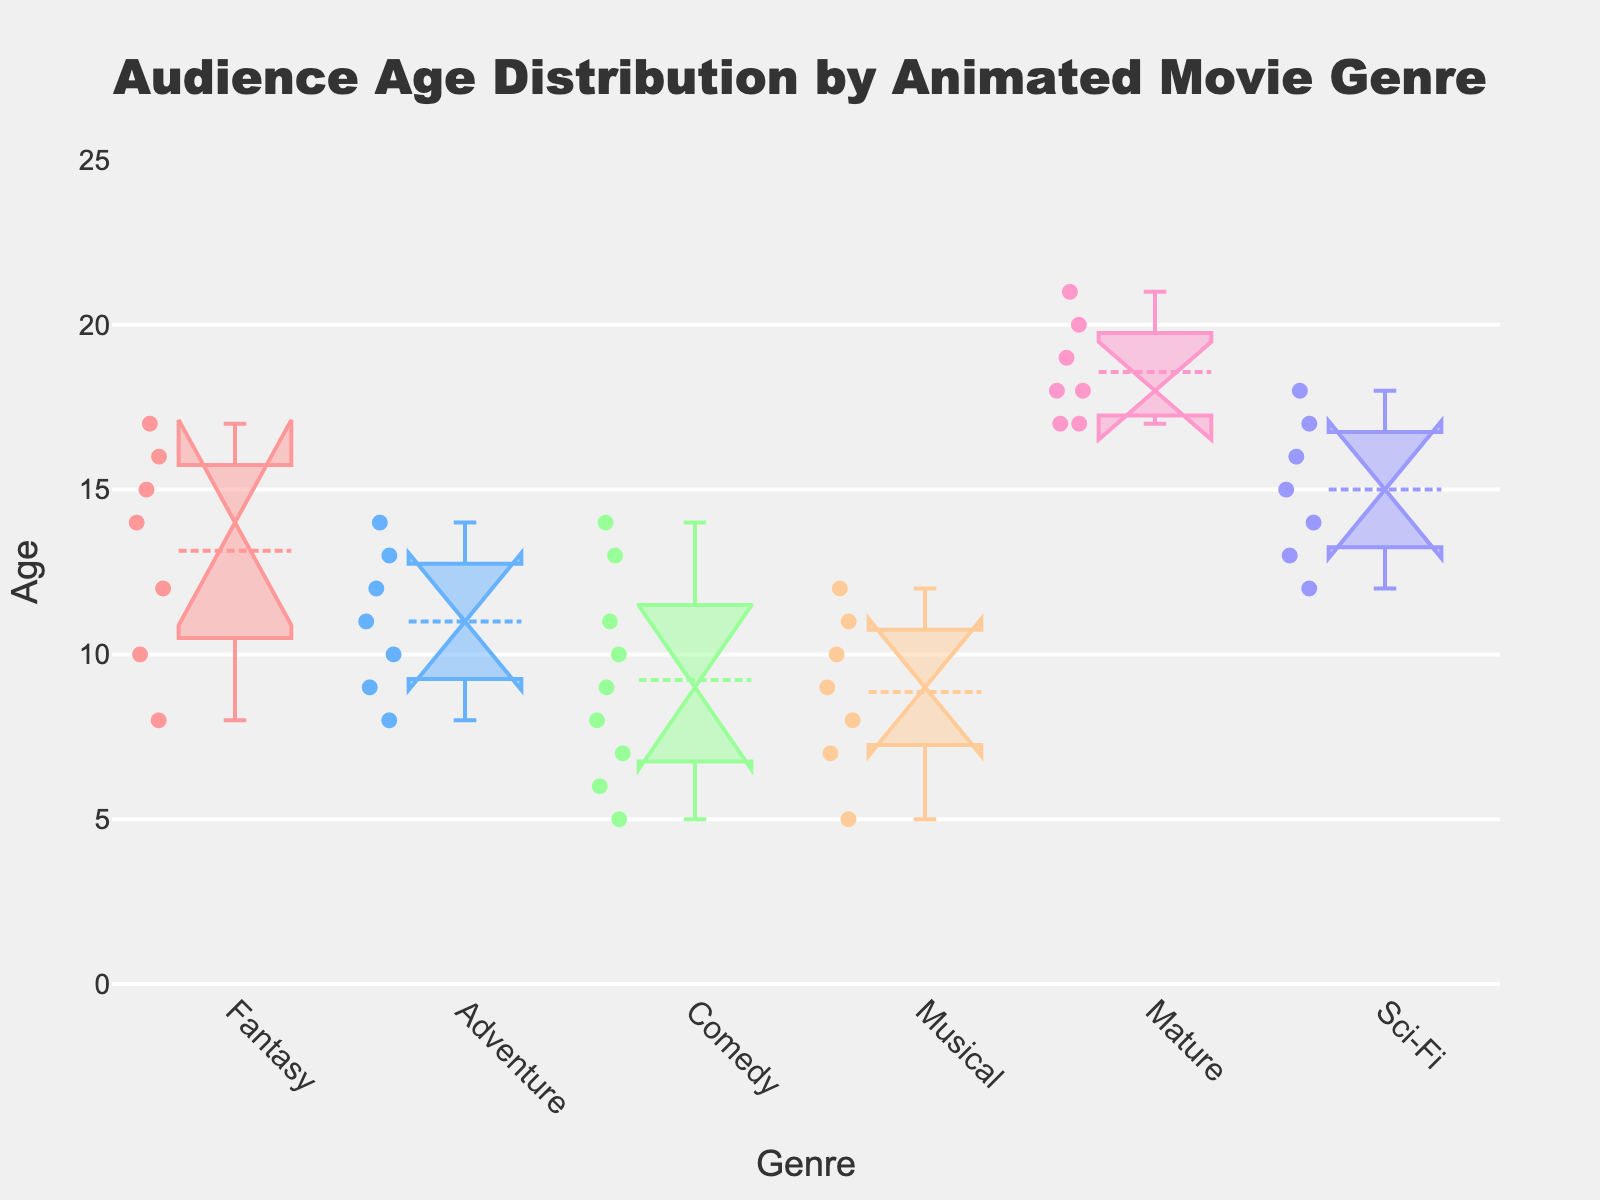What is the title of this plot? The title of the plot is displayed at the top center of the plot and reads "Audience Age Distribution by Animated Movie Genre".
Answer: Audience Age Distribution by Animated Movie Genre Which genre has the youngest audience on average? By observing the notches and the median lines within each box, the genre with the lowest median age is "Comedy", indicating the youngest audience on average.
Answer: Comedy What is the median age for the 'Mature' genre? The median age for the 'Mature' genre can be identified by looking at the horizontal line inside the box for 'Mature'. This line is at age 18.
Answer: 18 Which genre shows the largest spread in audience ages? To determine the largest spread, compare the length of the boxes (interquartile ranges) and the whiskers. The 'Mature' genre has the longest whiskers and box, indicating the largest spread.
Answer: Mature Do any genres have outliers? Outliers are shown as points outside the whiskers. In this plot, 'Fantasy' and 'Comedy' have individual points beyond the whiskers indicating outliers.
Answer: Fantasy, Comedy Which genre has the most narrow interquartile range? The interquartile range is the range covered by the box. 'Adventure' has the narrowest box, indicating the most narrow interquartile range.
Answer: Adventure Is the median age for 'Sci-Fi' higher or lower than for 'Musical'? Comparing the median lines within the boxes for 'Sci-Fi' and 'Musical', 'Sci-Fi' has a higher median age than 'Musical'.
Answer: Higher Which genres have overlapping notches, indicating similar medians? Notches that overlap imply that there’s no significant difference in medians. 'Adventure', 'Musical', and 'Comedy' have overlapping notches.
Answer: Adventure, Musical, Comedy What is the range of ages for the 'Fantasy' genre? The range can be determined by subtracting the lowest value from the highest value, which fall at the bottom and top whiskers, respectively. For 'Fantasy', it ranges from 8 to 17, giving a range of 9.
Answer: 9 Which genre has the highest age variability? The genre with the largest spread of the age data points has the highest variability. Based on the box plot lengths and whiskers, 'Mature' shows the highest age variability.
Answer: Mature 